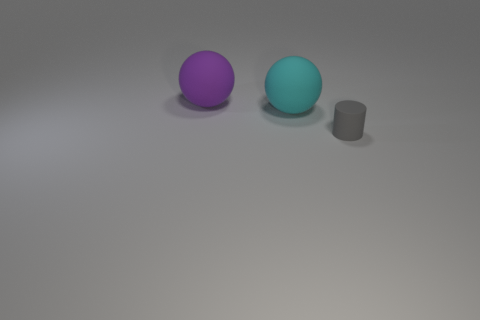What number of purple rubber things are the same size as the cyan rubber thing?
Keep it short and to the point. 1. There is a cylinder that is on the right side of the large purple matte sphere; what is it made of?
Provide a short and direct response. Rubber. What number of gray objects are the same shape as the cyan rubber object?
Your answer should be compact. 0. The gray thing that is made of the same material as the cyan thing is what shape?
Provide a succinct answer. Cylinder. What shape is the thing that is on the left side of the big rubber ball on the right side of the large matte ball on the left side of the cyan sphere?
Offer a very short reply. Sphere. Is the number of large red rubber cubes greater than the number of matte cylinders?
Provide a succinct answer. No. There is another big thing that is the same shape as the cyan object; what is its material?
Make the answer very short. Rubber. Does the large cyan thing have the same material as the tiny gray cylinder?
Your answer should be very brief. Yes. Are there more gray cylinders in front of the tiny matte cylinder than gray rubber objects?
Give a very brief answer. No. What material is the big sphere that is right of the sphere behind the ball that is in front of the large purple matte sphere made of?
Provide a short and direct response. Rubber. 